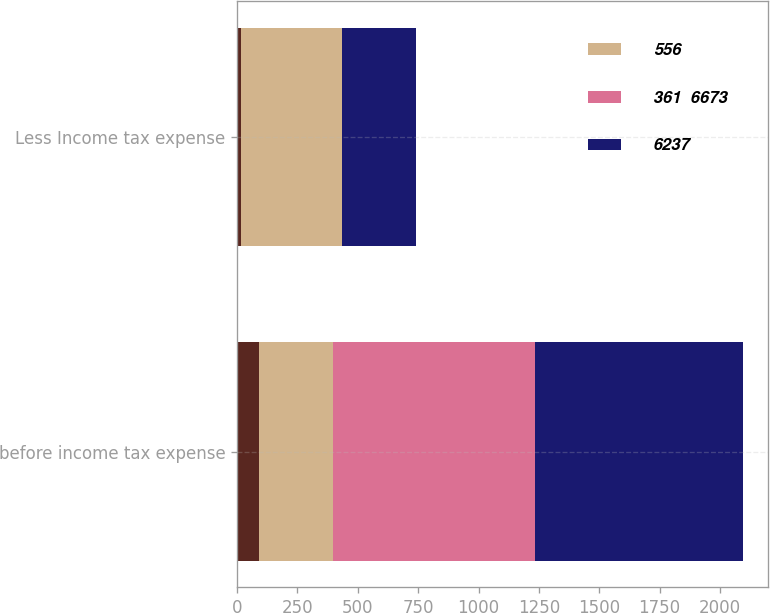<chart> <loc_0><loc_0><loc_500><loc_500><stacked_bar_chart><ecel><fcel>before income tax expense<fcel>Less Income tax expense<nl><fcel>nan<fcel>91<fcel>16<nl><fcel>556<fcel>308<fcel>418<nl><fcel>361  6673<fcel>833<fcel>1<nl><fcel>6237<fcel>864<fcel>308<nl></chart> 